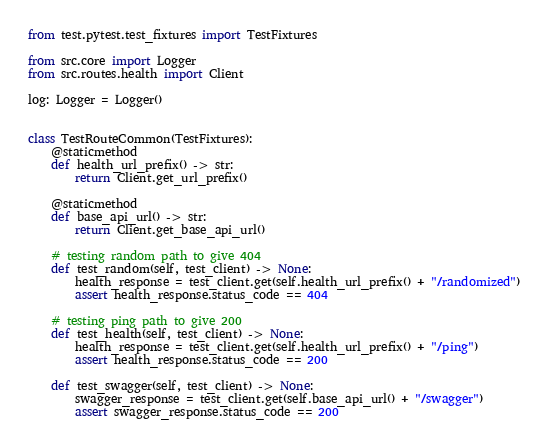Convert code to text. <code><loc_0><loc_0><loc_500><loc_500><_Python_>from test.pytest.test_fixtures import TestFixtures

from src.core import Logger
from src.routes.health import Client

log: Logger = Logger()


class TestRouteCommon(TestFixtures):
    @staticmethod
    def health_url_prefix() -> str:
        return Client.get_url_prefix()

    @staticmethod
    def base_api_url() -> str:
        return Client.get_base_api_url()

    # testing random path to give 404
    def test_random(self, test_client) -> None:
        health_response = test_client.get(self.health_url_prefix() + "/randomized")
        assert health_response.status_code == 404

    # testing ping path to give 200
    def test_health(self, test_client) -> None:
        health_response = test_client.get(self.health_url_prefix() + "/ping")
        assert health_response.status_code == 200

    def test_swagger(self, test_client) -> None:
        swagger_response = test_client.get(self.base_api_url() + "/swagger")
        assert swagger_response.status_code == 200
</code> 